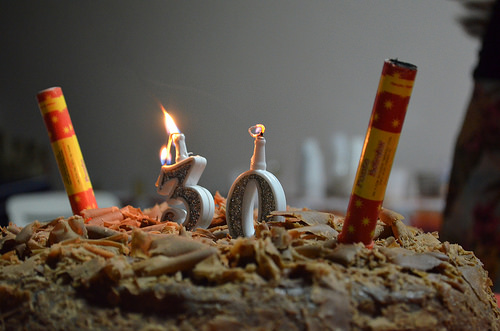<image>
Can you confirm if the candle is to the left of the candle? No. The candle is not to the left of the candle. From this viewpoint, they have a different horizontal relationship. 